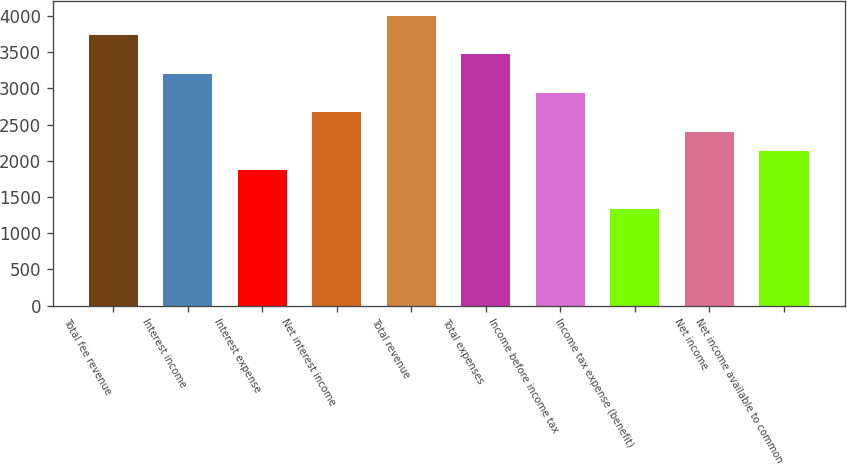Convert chart. <chart><loc_0><loc_0><loc_500><loc_500><bar_chart><fcel>Total fee revenue<fcel>Interest income<fcel>Interest expense<fcel>Net interest income<fcel>Total revenue<fcel>Total expenses<fcel>Income before income tax<fcel>Income tax expense (benefit)<fcel>Net income<fcel>Net income available to common<nl><fcel>3735.02<fcel>3201.5<fcel>1867.7<fcel>2667.98<fcel>4001.78<fcel>3468.26<fcel>2934.74<fcel>1334.18<fcel>2401.22<fcel>2134.46<nl></chart> 